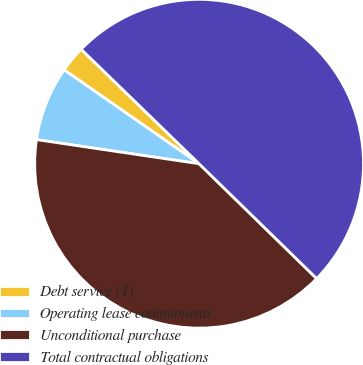<chart> <loc_0><loc_0><loc_500><loc_500><pie_chart><fcel>Debt service (1)<fcel>Operating lease commitments<fcel>Unconditional purchase<fcel>Total contractual obligations<nl><fcel>2.59%<fcel>7.33%<fcel>40.04%<fcel>50.05%<nl></chart> 